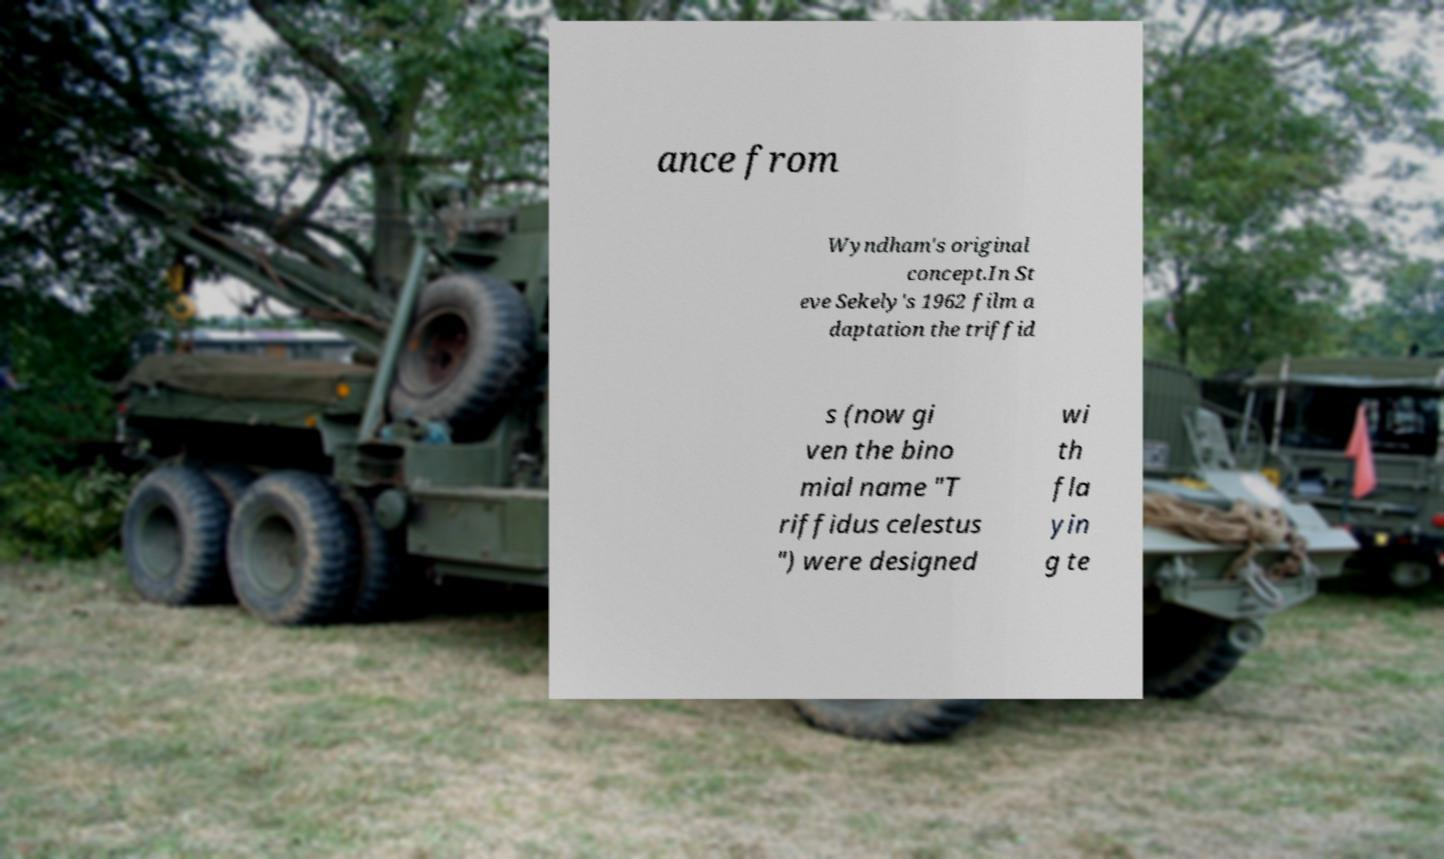There's text embedded in this image that I need extracted. Can you transcribe it verbatim? ance from Wyndham's original concept.In St eve Sekely's 1962 film a daptation the triffid s (now gi ven the bino mial name "T riffidus celestus ") were designed wi th fla yin g te 